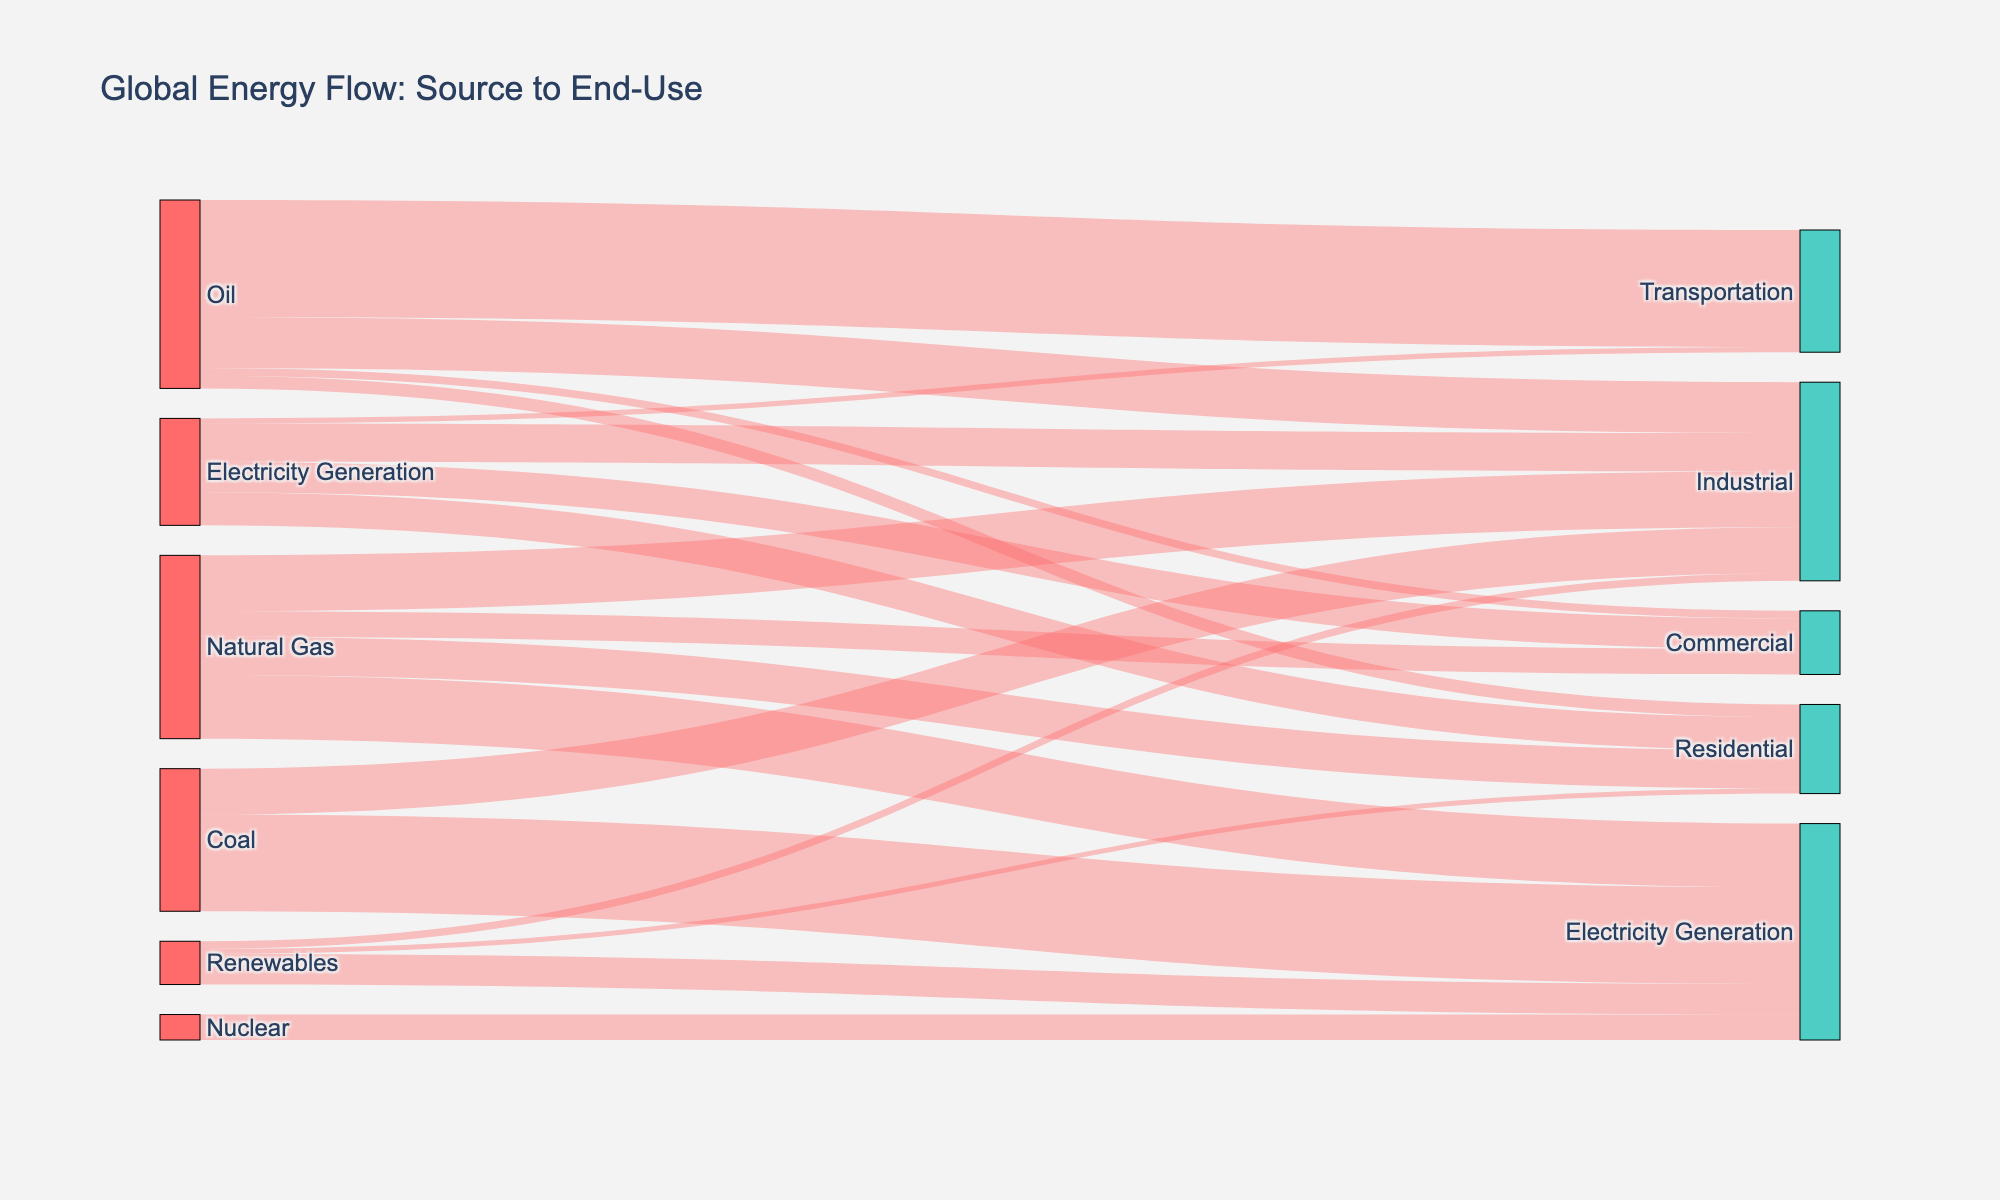What's the main source of energy for transportation? By examining the links starting from "Oil" and connected to different end-use sectors, we can see that the largest link from "Oil" goes to "Transportation" with a value of 46.
Answer: Oil Which energy source contributes most to electricity generation? Observing the links leading to "Electricity Generation," we see that "Coal" has the thickest link, with a value of 38, making it the largest contributor.
Answer: Coal What is the total amount of energy provided by renewables across all sectors? The links originating from "Renewables" are connected to "Electricity Generation" (12), "Industrial" (3), and "Residential" (2). Summing these values gives 12 + 3 + 2 = 17.
Answer: 17 How much energy is used by the residential sector from all sources? The residential sector receives energy from "Oil" (5), "Natural Gas" (15), "Renewables" (2), and "Electricity Generation" (13). Adding these amounts gives 5 + 15 + 2 + 13 = 35.
Answer: 35 Which source has a higher value for industrial use, Natural Gas or Coal? "Natural Gas" is connected to "Industrial" with a value of 22, whereas "Coal" is connected to "Industrial" with a value of 18. Comparing these values shows that "Natural Gas" has a higher value.
Answer: Natural Gas How much energy does electricity generation receive from all sources? "Electricity Generation" receives energy from "Natural Gas" (25), "Coal" (38), "Nuclear" (10), and "Renewables" (12). Adding these values gives 25 + 38 + 10 + 12 = 85.
Answer: 85 What is the combined energy value for industrial use across all sources? The industrial sector uses energy from "Oil" (20), "Natural Gas" (22), "Coal" (18), "Renewables" (3), and "Electricity Generation" (15). Summing these values results in 20 + 22 + 18 + 3 + 15 = 78.
Answer: 78 Which end-use sector receives the least amount of energy from electricity generation? Among the sectors using electricity generation, "Transportation" has the lowest value, with 2 units.
Answer: Transportation How much energy does oil provide in total across all sectors? The links from "Oil" show values of 46 (Transportation), 20 (Industrial), 5 (Residential), and 3 (Commercial). Adding these gives 46 + 20 + 5 + 3 = 74.
Answer: 74 What's the total energy consumption in the commercial sector? The commercial sector receives energy from "Oil" (3), "Natural Gas" (10), and "Electricity Generation" (12). Adding these values results in 3 + 10 + 12 = 25.
Answer: 25 